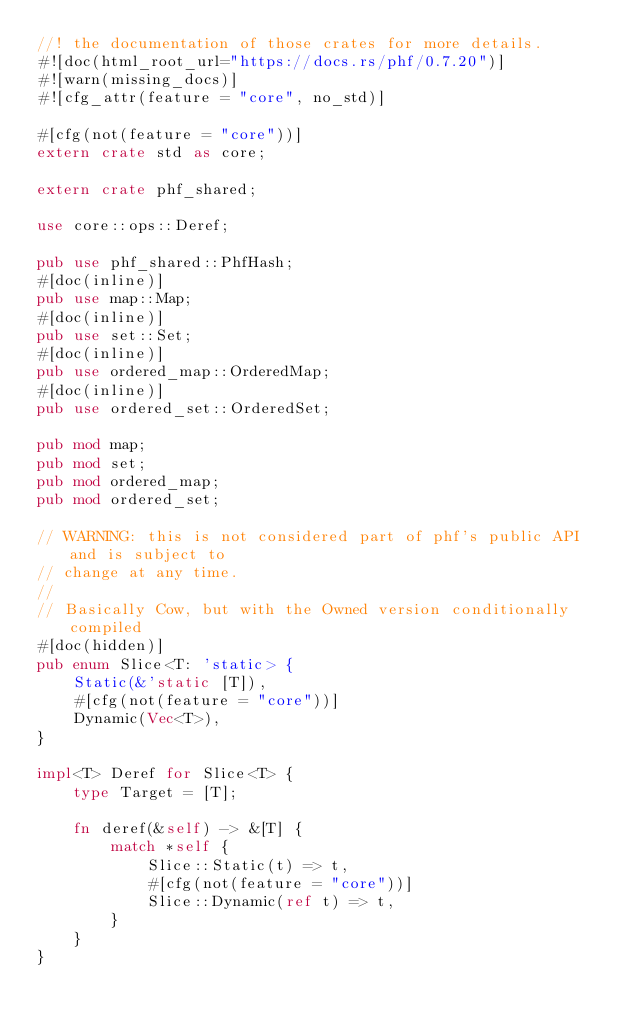Convert code to text. <code><loc_0><loc_0><loc_500><loc_500><_Rust_>//! the documentation of those crates for more details.
#![doc(html_root_url="https://docs.rs/phf/0.7.20")]
#![warn(missing_docs)]
#![cfg_attr(feature = "core", no_std)]

#[cfg(not(feature = "core"))]
extern crate std as core;

extern crate phf_shared;

use core::ops::Deref;

pub use phf_shared::PhfHash;
#[doc(inline)]
pub use map::Map;
#[doc(inline)]
pub use set::Set;
#[doc(inline)]
pub use ordered_map::OrderedMap;
#[doc(inline)]
pub use ordered_set::OrderedSet;

pub mod map;
pub mod set;
pub mod ordered_map;
pub mod ordered_set;

// WARNING: this is not considered part of phf's public API and is subject to
// change at any time.
//
// Basically Cow, but with the Owned version conditionally compiled
#[doc(hidden)]
pub enum Slice<T: 'static> {
    Static(&'static [T]),
    #[cfg(not(feature = "core"))]
    Dynamic(Vec<T>),
}

impl<T> Deref for Slice<T> {
    type Target = [T];

    fn deref(&self) -> &[T] {
        match *self {
            Slice::Static(t) => t,
            #[cfg(not(feature = "core"))]
            Slice::Dynamic(ref t) => t,
        }
    }
}
</code> 